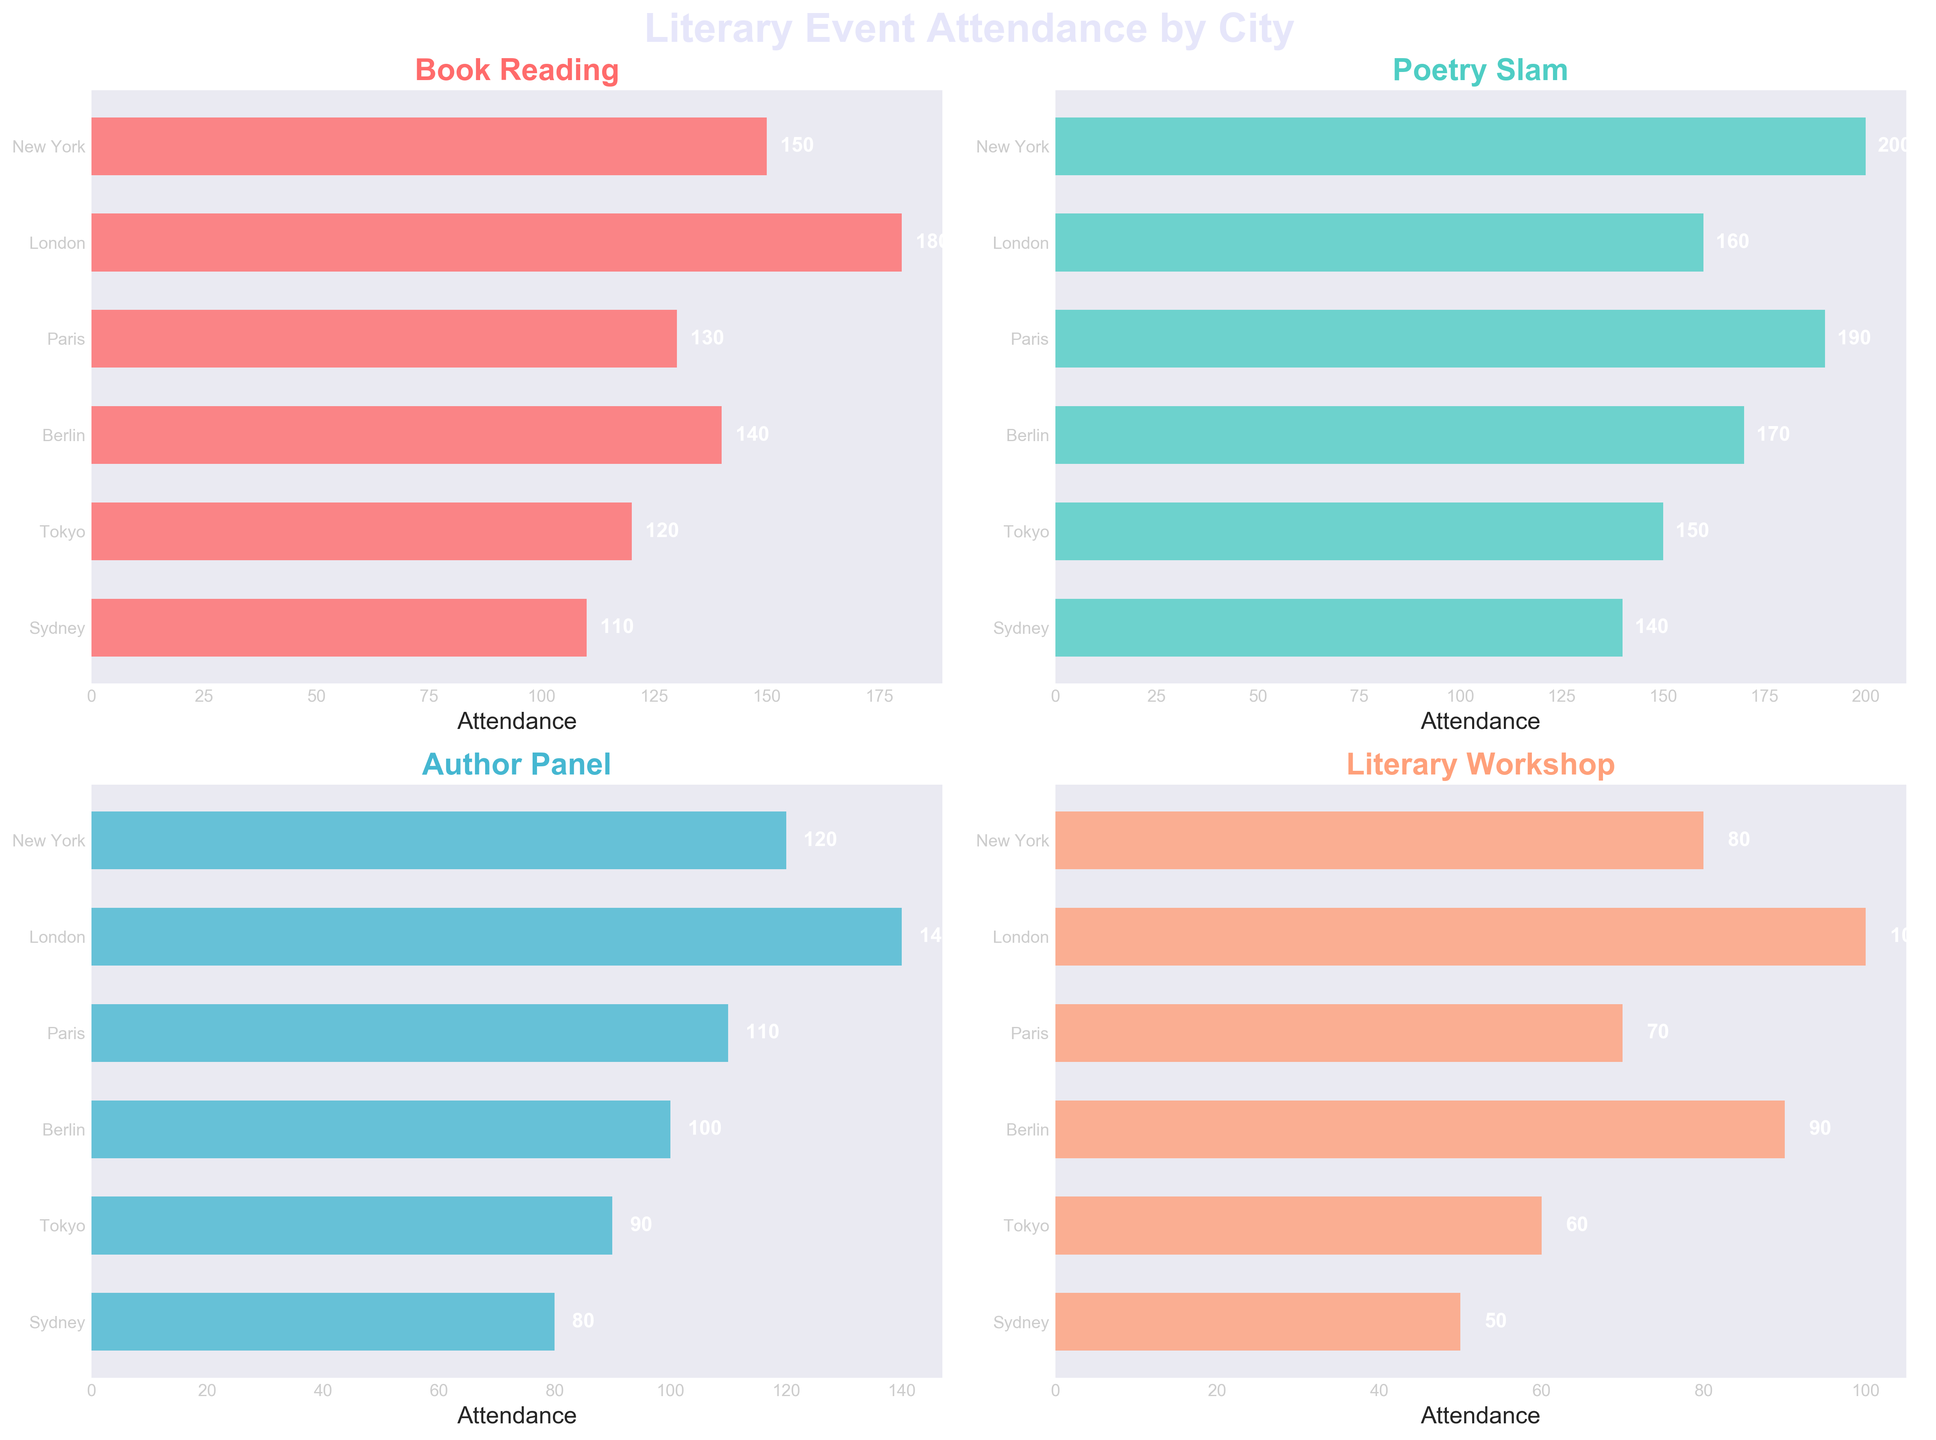How many cities have attendance figures shown in the plot? To find the number of cities, one can simply count the names listed on the vertical axis of any subplot. Each subplot represents data for the same number of cities.
Answer: 6 Which event has the highest attendance in London? The subplot titled 'Poetry Slam' shows that London's bar reaches the highest attendance value, so it represents the highest attendance for London's literary events.
Answer: Poetry Slam What is the total attendance for the Author Panel events across all cities? By adding the attendance values from the 'Author Panel' subplot for each city: New York (120), London (140), Paris (110), Berlin (100), Tokyo (90), and Sydney (80), we get 120 + 140 + 110 + 100 + 90 + 80 = 640.
Answer: 640 Between Paris and Berlin, which city had higher attendance for Book Reading? By checking the respective bars in the 'Book Reading' subplot, Paris has an attendance of 130 and Berlin has 140. Comparing these two values, Berlin has higher attendance.
Answer: Berlin What's the average attendance for all events in New York? Adding up the figures for New York across all events (150 + 200 + 120 + 80) yields 550. The number of events is 4, so the average is 550/4 = 137.5.
Answer: 137.5 Which city had the lowest attendance for the Literary Workshop event? By observing the bars in the 'Literary Workshop' subplot, Sydney has the lowest attendance with a value of 50.
Answer: Sydney What is the difference in the number of attendees between New York and Sydney for the Poetry Slam event? Subtract the attendance figure for Sydney's Poetry Slam (140) from New York's Poetry Slam (200), which results in 200 - 140 = 60.
Answer: 60 Among all events, which one had the second highest attendance figure, and in which city? First, identify the highest attendance and then the second highest. The highest is Poetry Slam in New York (200). The second highest is Poetry Slam in Paris with 190.
Answer: Poetry Slam in Paris How does the attendance for Book Reading in Tokyo compare with that in Sydney? In the 'Book Reading' subplot, Tokyo shows 120 while Sydney shows 110. Since 120 is greater than 110, Tokyo has higher attendance.
Answer: Tokyo Which event shows the smallest variation in attendance figures across all cities? Observing all subplots, 'Author Panel' shows the smallest variation in bar heights across cities, indicating the most consistent attendance figures.
Answer: Author Panel 